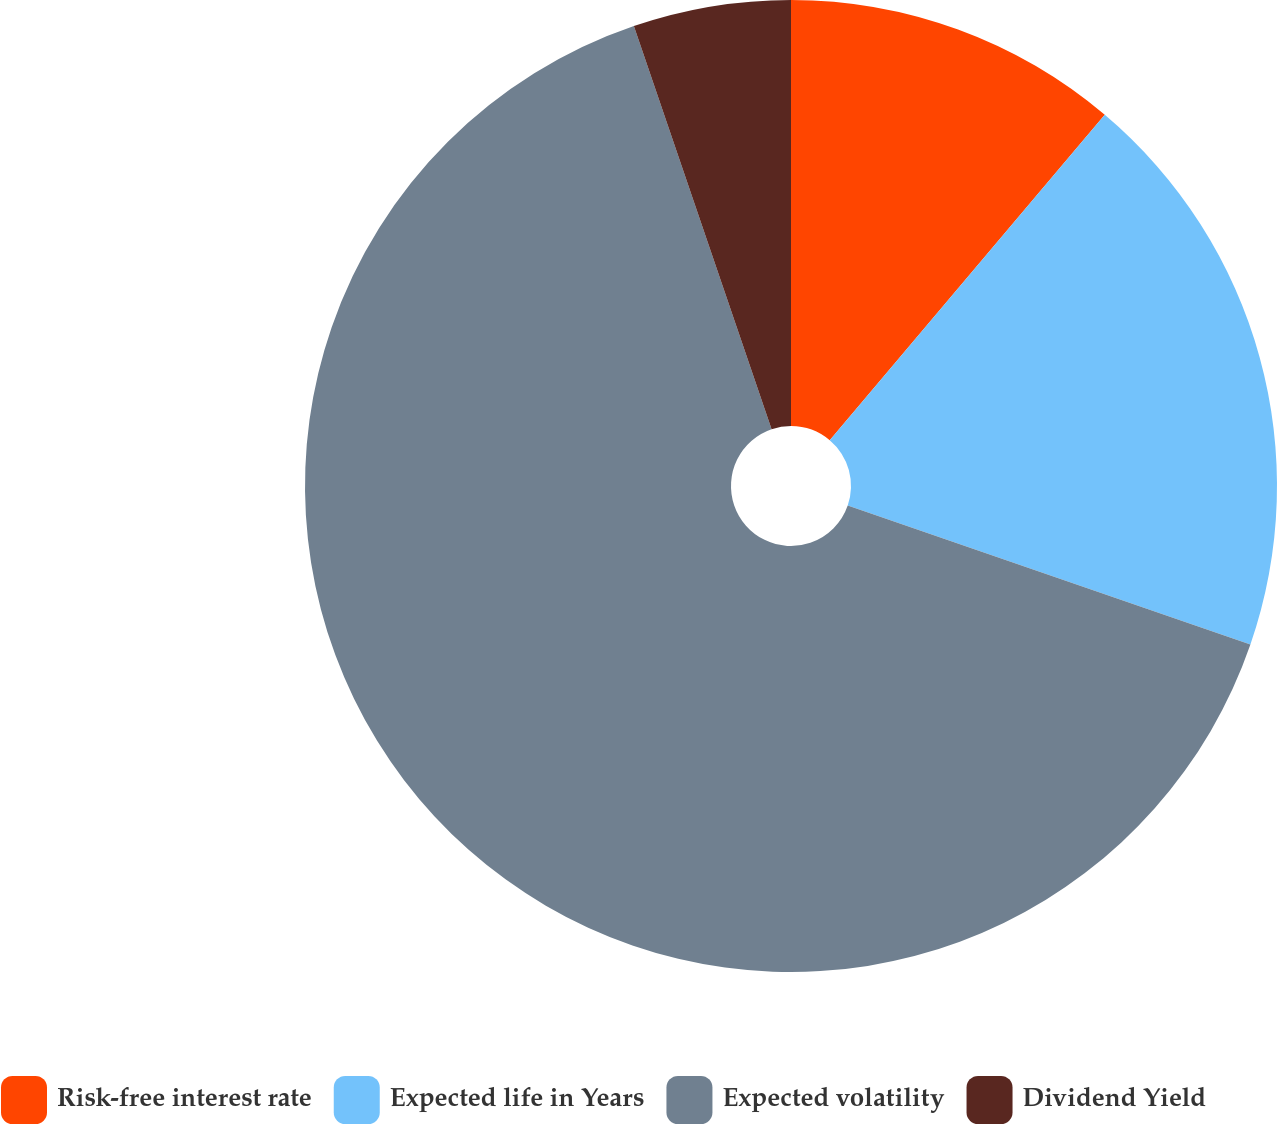Convert chart to OTSL. <chart><loc_0><loc_0><loc_500><loc_500><pie_chart><fcel>Risk-free interest rate<fcel>Expected life in Years<fcel>Expected volatility<fcel>Dividend Yield<nl><fcel>11.17%<fcel>19.12%<fcel>64.47%<fcel>5.24%<nl></chart> 